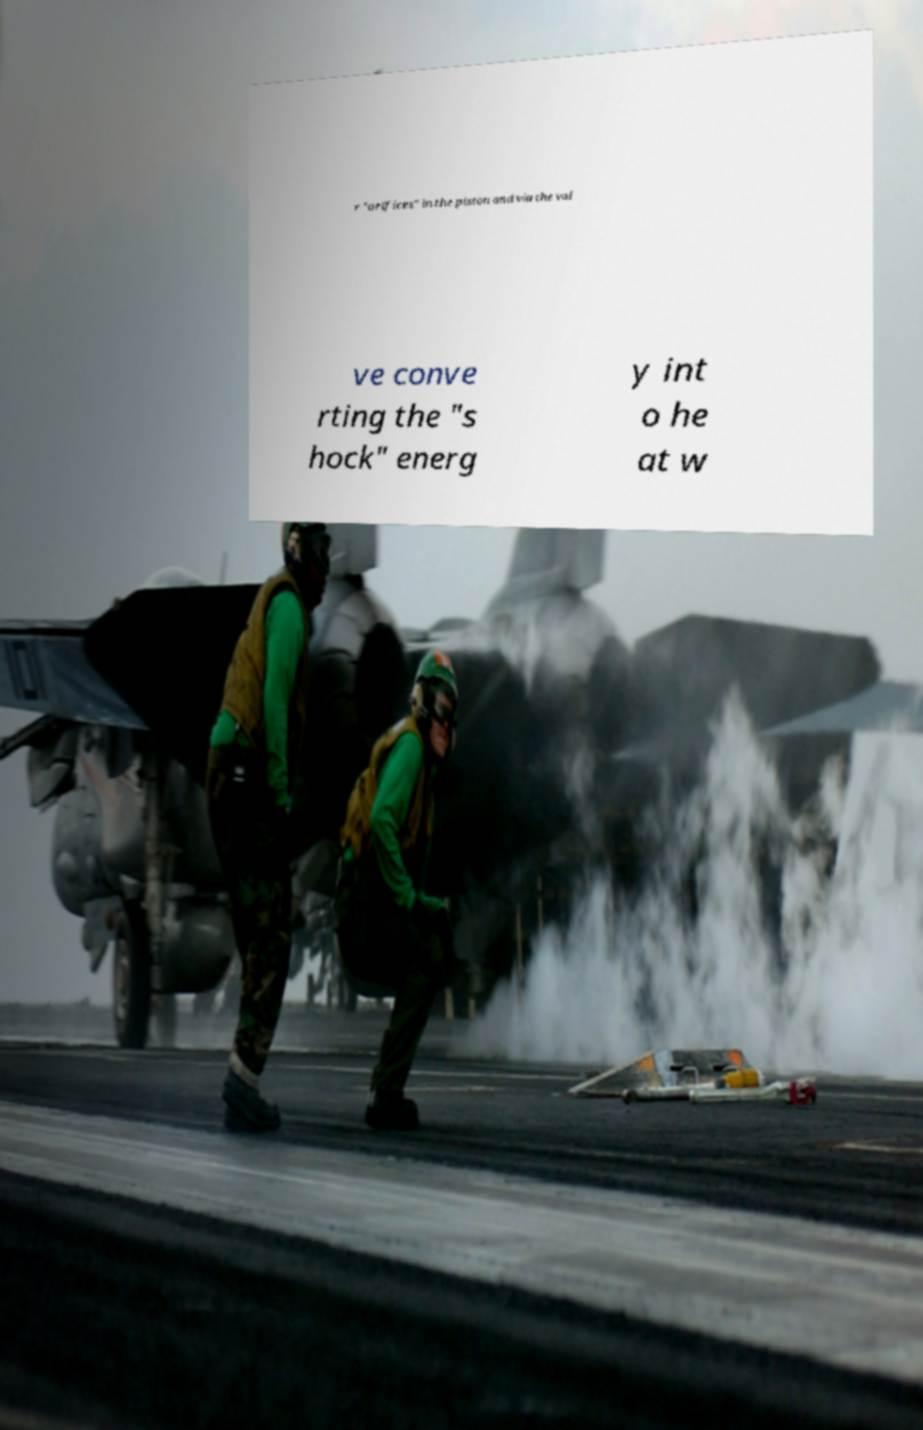There's text embedded in this image that I need extracted. Can you transcribe it verbatim? r "orifices" in the piston and via the val ve conve rting the "s hock" energ y int o he at w 